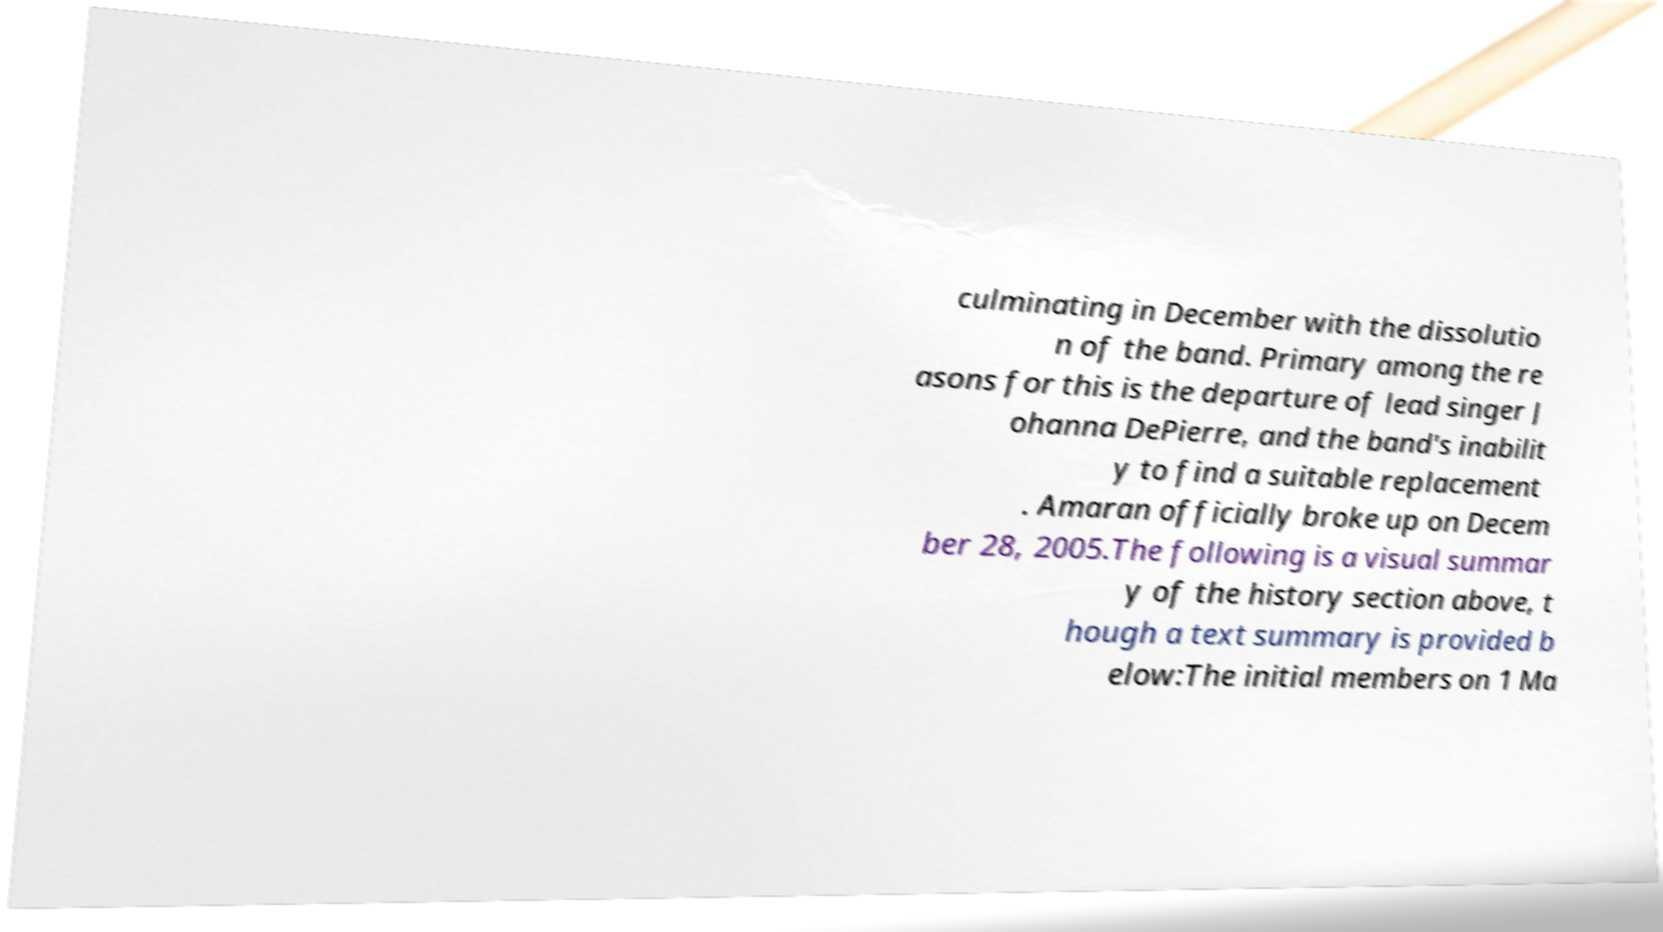Could you assist in decoding the text presented in this image and type it out clearly? culminating in December with the dissolutio n of the band. Primary among the re asons for this is the departure of lead singer J ohanna DePierre, and the band's inabilit y to find a suitable replacement . Amaran officially broke up on Decem ber 28, 2005.The following is a visual summar y of the history section above, t hough a text summary is provided b elow:The initial members on 1 Ma 